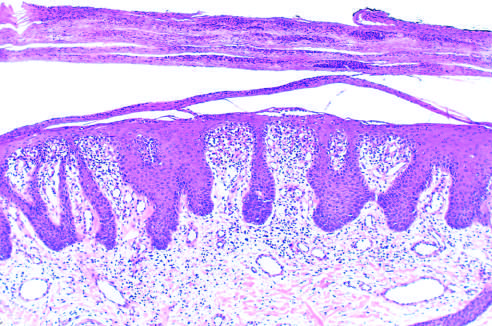does rupture of a meningeal artery, usually associated with a skull fracture, show marked epidermal hyperplasia, downward extension of rete ridges, and prominent parakeratotic scale with infiltrating neutrophils?
Answer the question using a single word or phrase. No 